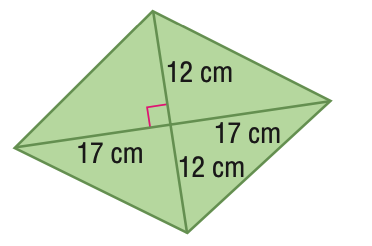Answer the mathemtical geometry problem and directly provide the correct option letter.
Question: Find the area of the figure. Round to the nearest tenth if necessary.
Choices: A: 204 B: 289 C: 408 D: 916 C 